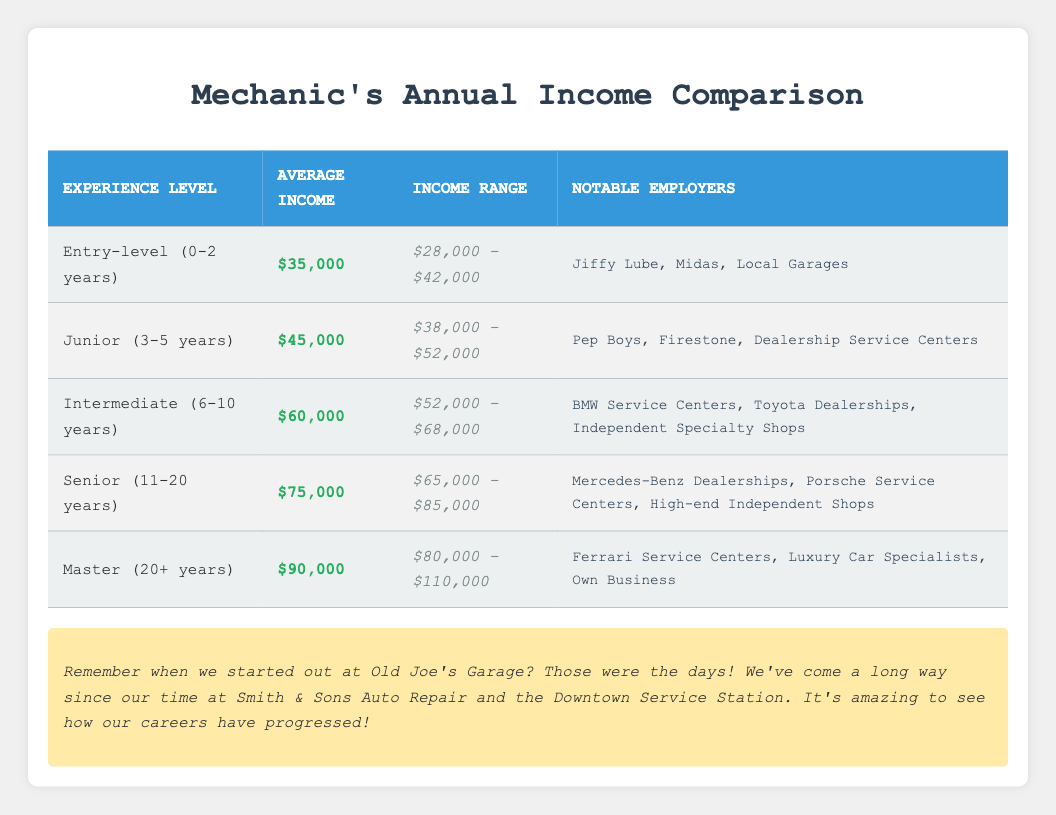What is the average income for a Junior mechanic? The average income for a Junior mechanic, as listed in the table, is $45,000.
Answer: $45,000 How much does an Entry-level mechanic earn at most? The high range for an Entry-level mechanic's income is $42,000, as shown in the table.
Answer: $42,000 Which experience level has the highest average income? The Master experience level, with an average income of $90,000, has the highest average compared to the other levels listed in the table.
Answer: Master (20+ years) Is it true that Senior mechanics earn more than Intermediate mechanics? Yes, the average income for Senior mechanics is $75,000, while for Intermediate mechanics it is $60,000, which confirms that Seniors earn more.
Answer: Yes What is the difference in average income between Junior and Senior mechanics? The average income for Junior mechanics is $45,000 and for Senior mechanics it is $75,000. The difference is calculated as $75,000 - $45,000 = $30,000.
Answer: $30,000 How many notable employers are listed for Intermediate mechanics? There are three notable employers listed for Intermediate mechanics: BMW Service Centers, Toyota Dealerships, and Independent Specialty Shops, as seen in the table.
Answer: 3 Which experience level shows the lowest income range? The Entry-level experience level shows the lowest income range of $28,000 to $42,000 when compared to other ranges listed in the table.
Answer: Entry-level (0-2 years) What is the average income range for a Master mechanic? The average income range for a Master mechanic is between $80,000 and $110,000, as recorded in the table.
Answer: $80,000 - $110,000 If an Intermediate mechanic earns $65,000, does this fall within their income range? Yes, the income range for Intermediate mechanics is $52,000 to $68,000, which includes $65,000, confirming it falls within the range.
Answer: Yes 